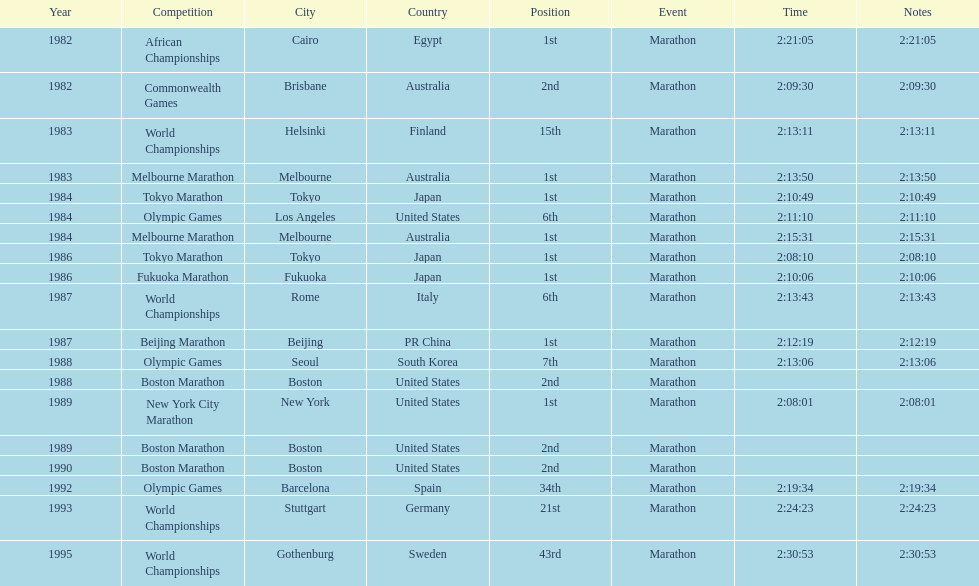What were the number of times the venue was located in the united states? 5. 